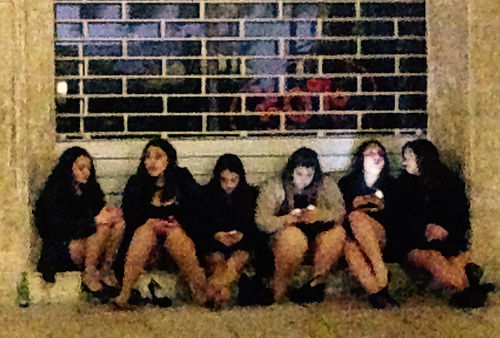<image>
Is the girl to the left of the fat girl? Yes. From this viewpoint, the girl is positioned to the left side relative to the fat girl. 